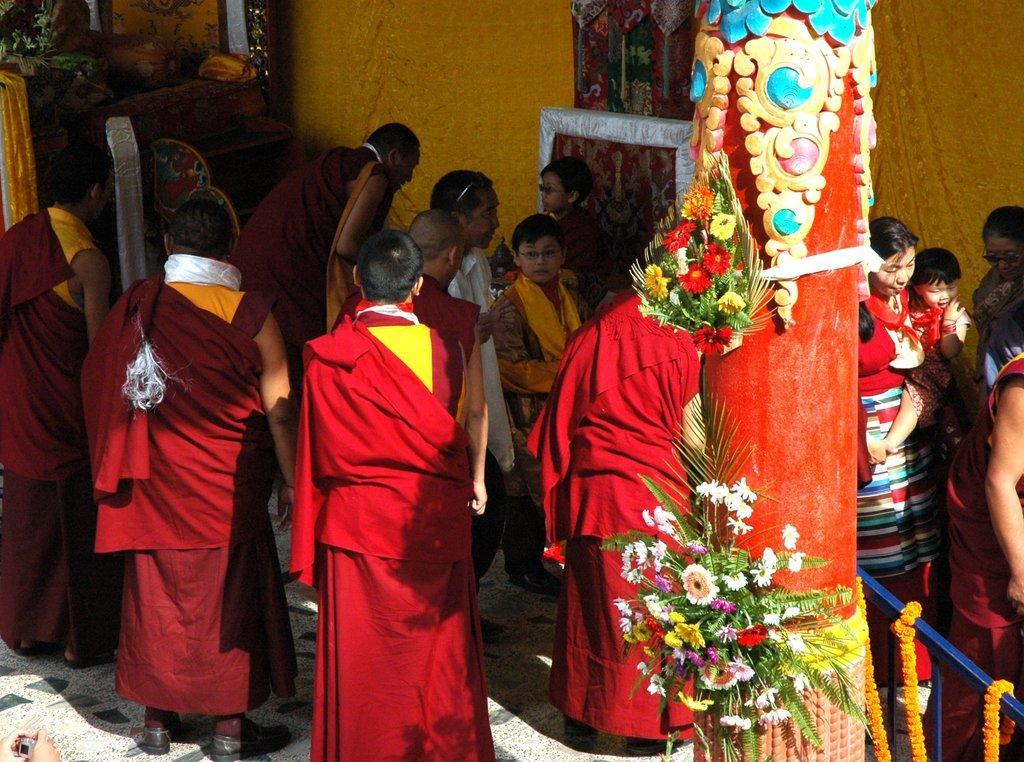Describe this image in one or two sentences. In this image there a few people, few flowers attached to the pillar, there is a fence decorated with garland and few plants. 